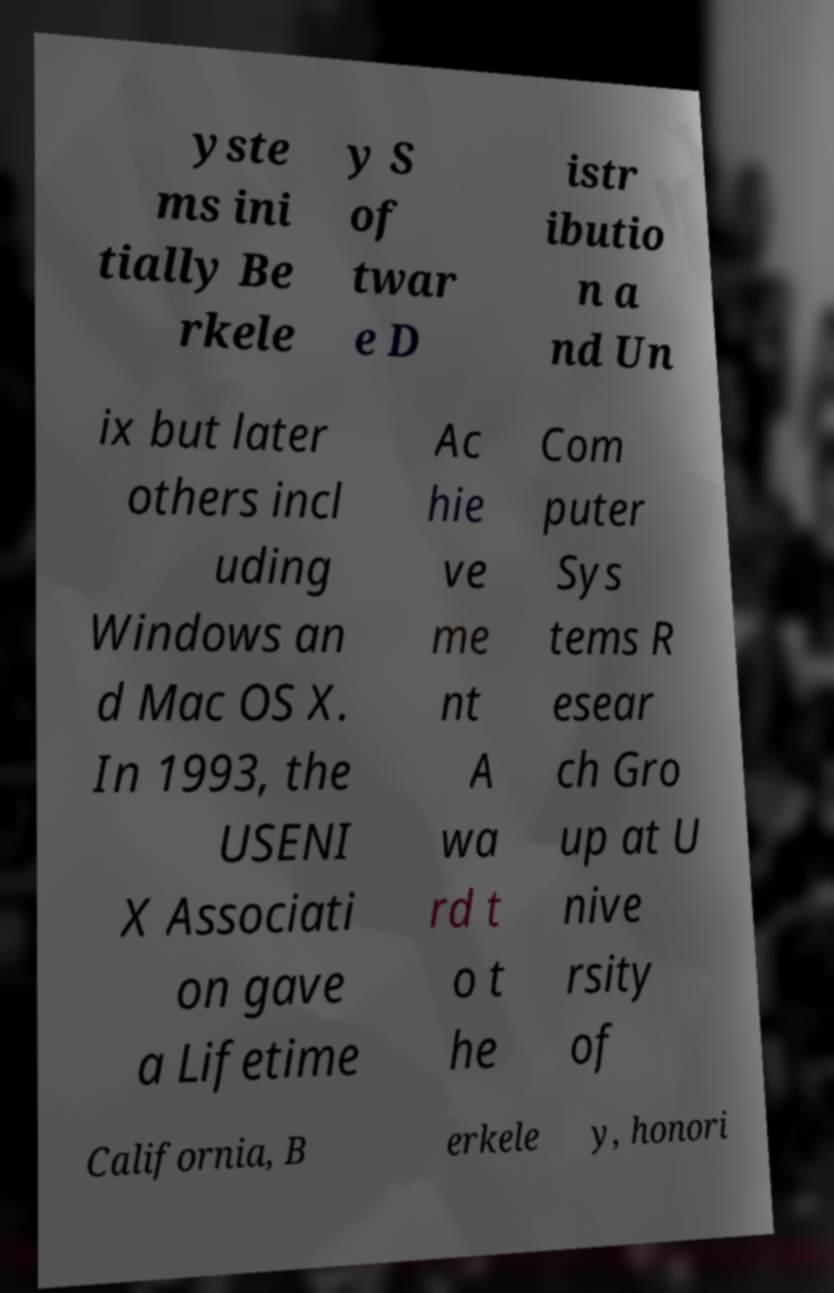What messages or text are displayed in this image? I need them in a readable, typed format. yste ms ini tially Be rkele y S of twar e D istr ibutio n a nd Un ix but later others incl uding Windows an d Mac OS X. In 1993, the USENI X Associati on gave a Lifetime Ac hie ve me nt A wa rd t o t he Com puter Sys tems R esear ch Gro up at U nive rsity of California, B erkele y, honori 